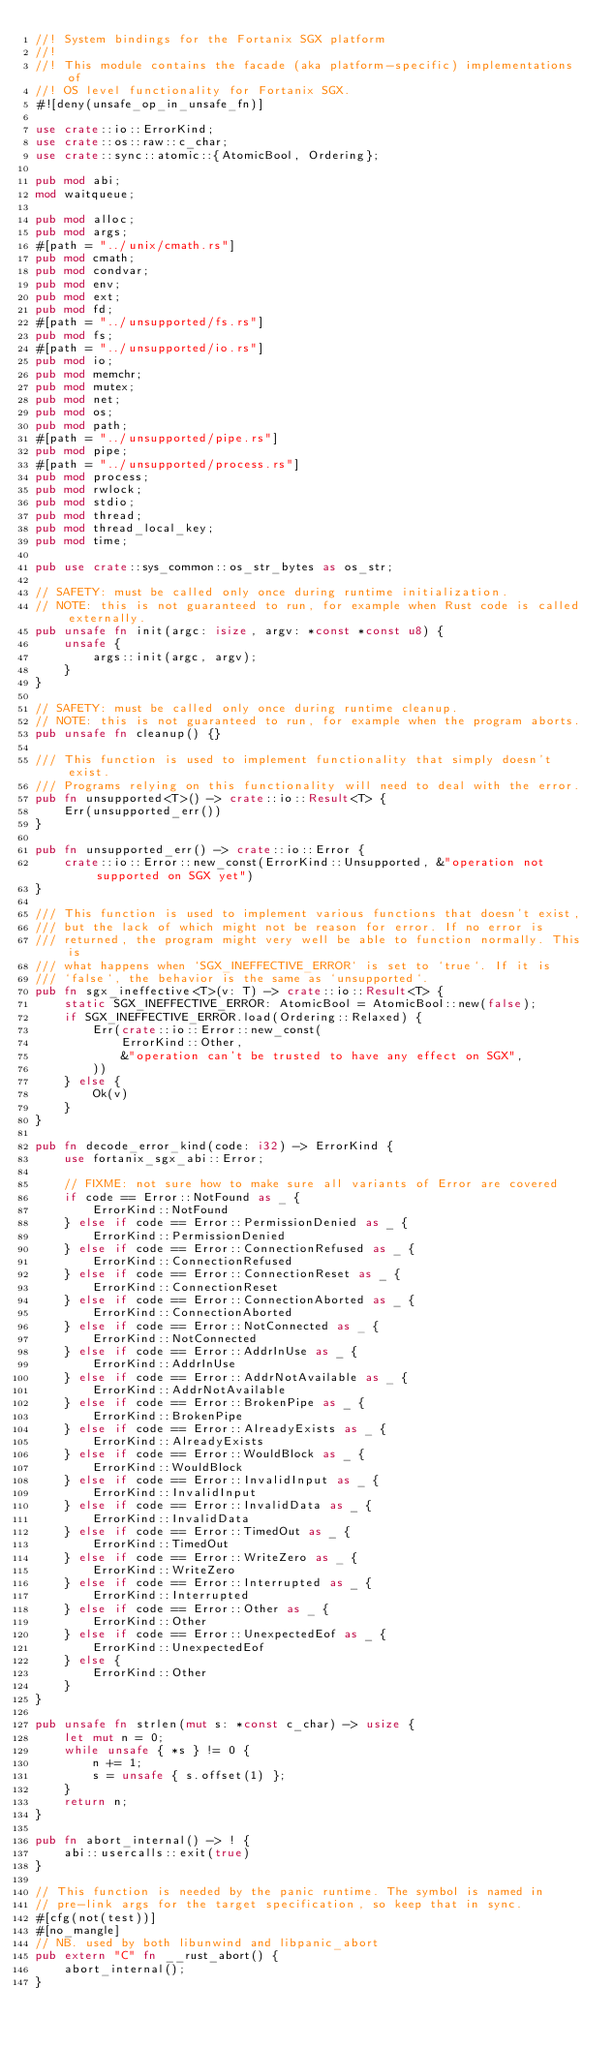<code> <loc_0><loc_0><loc_500><loc_500><_Rust_>//! System bindings for the Fortanix SGX platform
//!
//! This module contains the facade (aka platform-specific) implementations of
//! OS level functionality for Fortanix SGX.
#![deny(unsafe_op_in_unsafe_fn)]

use crate::io::ErrorKind;
use crate::os::raw::c_char;
use crate::sync::atomic::{AtomicBool, Ordering};

pub mod abi;
mod waitqueue;

pub mod alloc;
pub mod args;
#[path = "../unix/cmath.rs"]
pub mod cmath;
pub mod condvar;
pub mod env;
pub mod ext;
pub mod fd;
#[path = "../unsupported/fs.rs"]
pub mod fs;
#[path = "../unsupported/io.rs"]
pub mod io;
pub mod memchr;
pub mod mutex;
pub mod net;
pub mod os;
pub mod path;
#[path = "../unsupported/pipe.rs"]
pub mod pipe;
#[path = "../unsupported/process.rs"]
pub mod process;
pub mod rwlock;
pub mod stdio;
pub mod thread;
pub mod thread_local_key;
pub mod time;

pub use crate::sys_common::os_str_bytes as os_str;

// SAFETY: must be called only once during runtime initialization.
// NOTE: this is not guaranteed to run, for example when Rust code is called externally.
pub unsafe fn init(argc: isize, argv: *const *const u8) {
    unsafe {
        args::init(argc, argv);
    }
}

// SAFETY: must be called only once during runtime cleanup.
// NOTE: this is not guaranteed to run, for example when the program aborts.
pub unsafe fn cleanup() {}

/// This function is used to implement functionality that simply doesn't exist.
/// Programs relying on this functionality will need to deal with the error.
pub fn unsupported<T>() -> crate::io::Result<T> {
    Err(unsupported_err())
}

pub fn unsupported_err() -> crate::io::Error {
    crate::io::Error::new_const(ErrorKind::Unsupported, &"operation not supported on SGX yet")
}

/// This function is used to implement various functions that doesn't exist,
/// but the lack of which might not be reason for error. If no error is
/// returned, the program might very well be able to function normally. This is
/// what happens when `SGX_INEFFECTIVE_ERROR` is set to `true`. If it is
/// `false`, the behavior is the same as `unsupported`.
pub fn sgx_ineffective<T>(v: T) -> crate::io::Result<T> {
    static SGX_INEFFECTIVE_ERROR: AtomicBool = AtomicBool::new(false);
    if SGX_INEFFECTIVE_ERROR.load(Ordering::Relaxed) {
        Err(crate::io::Error::new_const(
            ErrorKind::Other,
            &"operation can't be trusted to have any effect on SGX",
        ))
    } else {
        Ok(v)
    }
}

pub fn decode_error_kind(code: i32) -> ErrorKind {
    use fortanix_sgx_abi::Error;

    // FIXME: not sure how to make sure all variants of Error are covered
    if code == Error::NotFound as _ {
        ErrorKind::NotFound
    } else if code == Error::PermissionDenied as _ {
        ErrorKind::PermissionDenied
    } else if code == Error::ConnectionRefused as _ {
        ErrorKind::ConnectionRefused
    } else if code == Error::ConnectionReset as _ {
        ErrorKind::ConnectionReset
    } else if code == Error::ConnectionAborted as _ {
        ErrorKind::ConnectionAborted
    } else if code == Error::NotConnected as _ {
        ErrorKind::NotConnected
    } else if code == Error::AddrInUse as _ {
        ErrorKind::AddrInUse
    } else if code == Error::AddrNotAvailable as _ {
        ErrorKind::AddrNotAvailable
    } else if code == Error::BrokenPipe as _ {
        ErrorKind::BrokenPipe
    } else if code == Error::AlreadyExists as _ {
        ErrorKind::AlreadyExists
    } else if code == Error::WouldBlock as _ {
        ErrorKind::WouldBlock
    } else if code == Error::InvalidInput as _ {
        ErrorKind::InvalidInput
    } else if code == Error::InvalidData as _ {
        ErrorKind::InvalidData
    } else if code == Error::TimedOut as _ {
        ErrorKind::TimedOut
    } else if code == Error::WriteZero as _ {
        ErrorKind::WriteZero
    } else if code == Error::Interrupted as _ {
        ErrorKind::Interrupted
    } else if code == Error::Other as _ {
        ErrorKind::Other
    } else if code == Error::UnexpectedEof as _ {
        ErrorKind::UnexpectedEof
    } else {
        ErrorKind::Other
    }
}

pub unsafe fn strlen(mut s: *const c_char) -> usize {
    let mut n = 0;
    while unsafe { *s } != 0 {
        n += 1;
        s = unsafe { s.offset(1) };
    }
    return n;
}

pub fn abort_internal() -> ! {
    abi::usercalls::exit(true)
}

// This function is needed by the panic runtime. The symbol is named in
// pre-link args for the target specification, so keep that in sync.
#[cfg(not(test))]
#[no_mangle]
// NB. used by both libunwind and libpanic_abort
pub extern "C" fn __rust_abort() {
    abort_internal();
}
</code> 